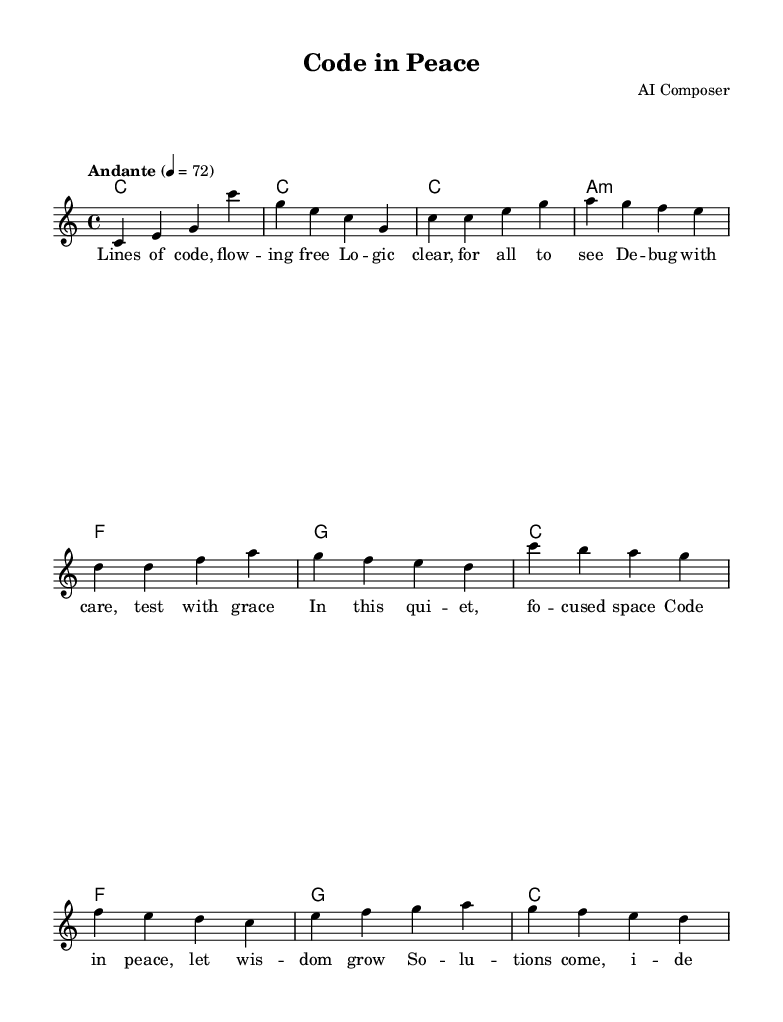What is the key signature of this music? The key signature is C major, which is indicated by the absence of sharps or flats. This can be identified in the global section of the code where the key is set to "c major."
Answer: C major What is the time signature of this music? The time signature is 4/4, which is found in the global section of the code where it states "time 4/4." This indicates that there are four beats in a measure, and a quarter note receives one beat.
Answer: 4/4 What is the tempo marking for this piece? The tempo marking is "Andante," set to a quarter note equals 72 beats per minute. This can be referenced in the global section of the code.
Answer: Andante How many measures are in the verse? The verse consists of four measures, which can be seen in the melody section where there are four distinct bars shown from "c c e g" to "g f e d."
Answer: Four What is the overall theme of the lyrics? The overall theme focuses on coding, concentration, and the calmness during development. The lyrics mention flowing code, clear logic, and the serenity of the coding space, highlighting a connection between coding and a meditative state.
Answer: Coding and concentration Which chord is used in the first measure? The chord used in the first measure is C major, indicated by "c1" in the harmonies section. This shows that the first chord played is a C major chord and it sets the tonal center for the piece.
Answer: C major What is the mood conveyed through the song’s structure? The mood conveyed is serene and introspective, as indicated by the calm tempo marking (Andante) and lyrics focusing on peaceful coding. This reflects a meditative atmosphere that fosters focus and concentration during coding sessions.
Answer: Serene 